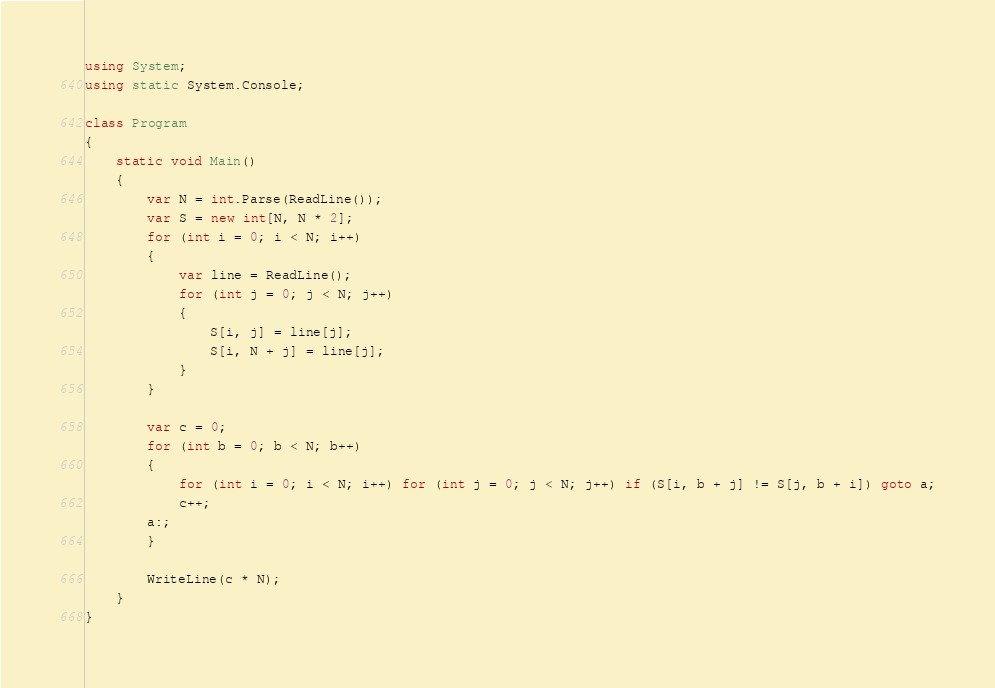Convert code to text. <code><loc_0><loc_0><loc_500><loc_500><_C#_>using System;
using static System.Console;

class Program
{
    static void Main()
    {
        var N = int.Parse(ReadLine());
        var S = new int[N, N * 2];
        for (int i = 0; i < N; i++)
        {
            var line = ReadLine();
            for (int j = 0; j < N; j++)
            {
                S[i, j] = line[j];
                S[i, N + j] = line[j];
            }
        }

        var c = 0;
        for (int b = 0; b < N; b++)
        {
            for (int i = 0; i < N; i++) for (int j = 0; j < N; j++) if (S[i, b + j] != S[j, b + i]) goto a;
            c++;
        a:;
        }

        WriteLine(c * N);
    }
}</code> 